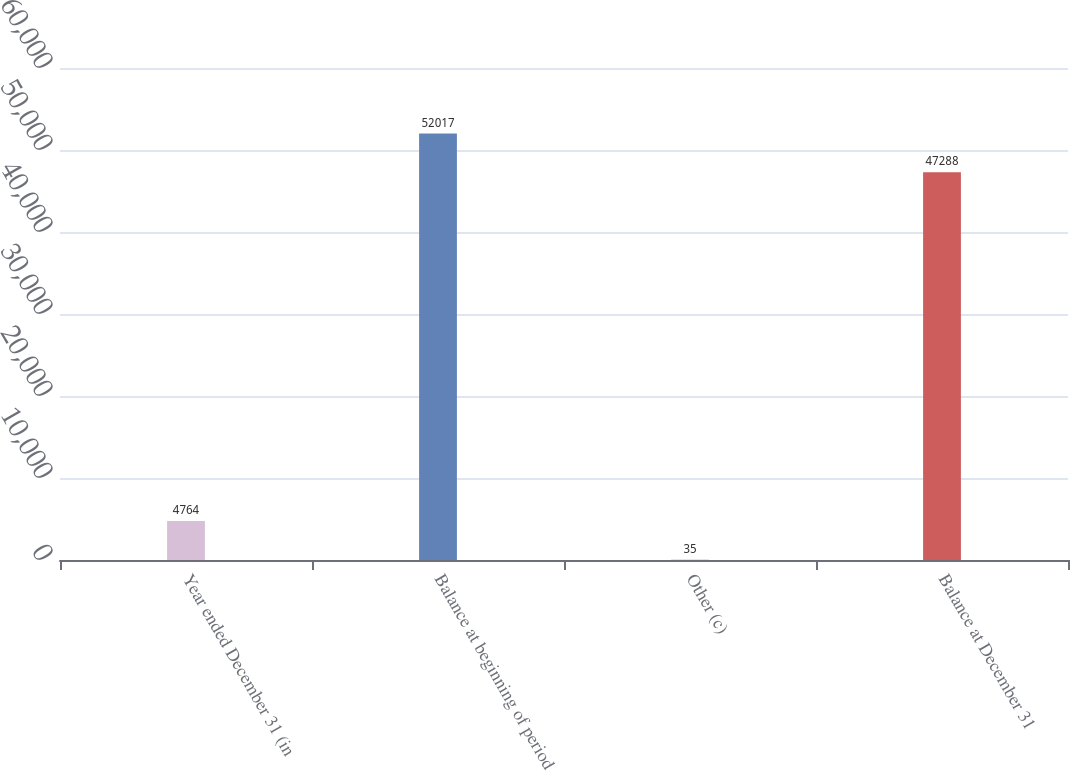Convert chart to OTSL. <chart><loc_0><loc_0><loc_500><loc_500><bar_chart><fcel>Year ended December 31 (in<fcel>Balance at beginning of period<fcel>Other (c)<fcel>Balance at December 31<nl><fcel>4764<fcel>52017<fcel>35<fcel>47288<nl></chart> 